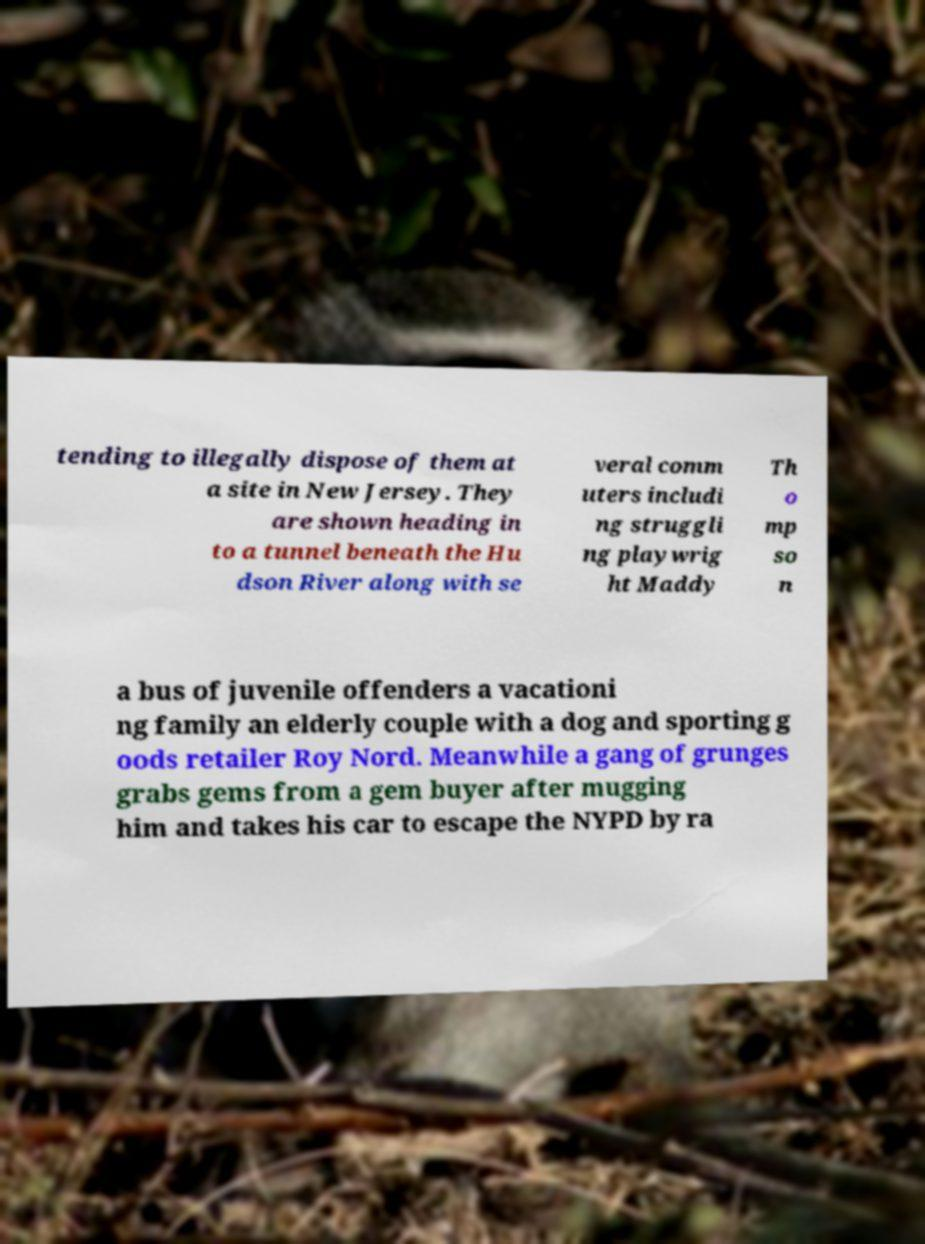Could you extract and type out the text from this image? tending to illegally dispose of them at a site in New Jersey. They are shown heading in to a tunnel beneath the Hu dson River along with se veral comm uters includi ng struggli ng playwrig ht Maddy Th o mp so n a bus of juvenile offenders a vacationi ng family an elderly couple with a dog and sporting g oods retailer Roy Nord. Meanwhile a gang of grunges grabs gems from a gem buyer after mugging him and takes his car to escape the NYPD by ra 